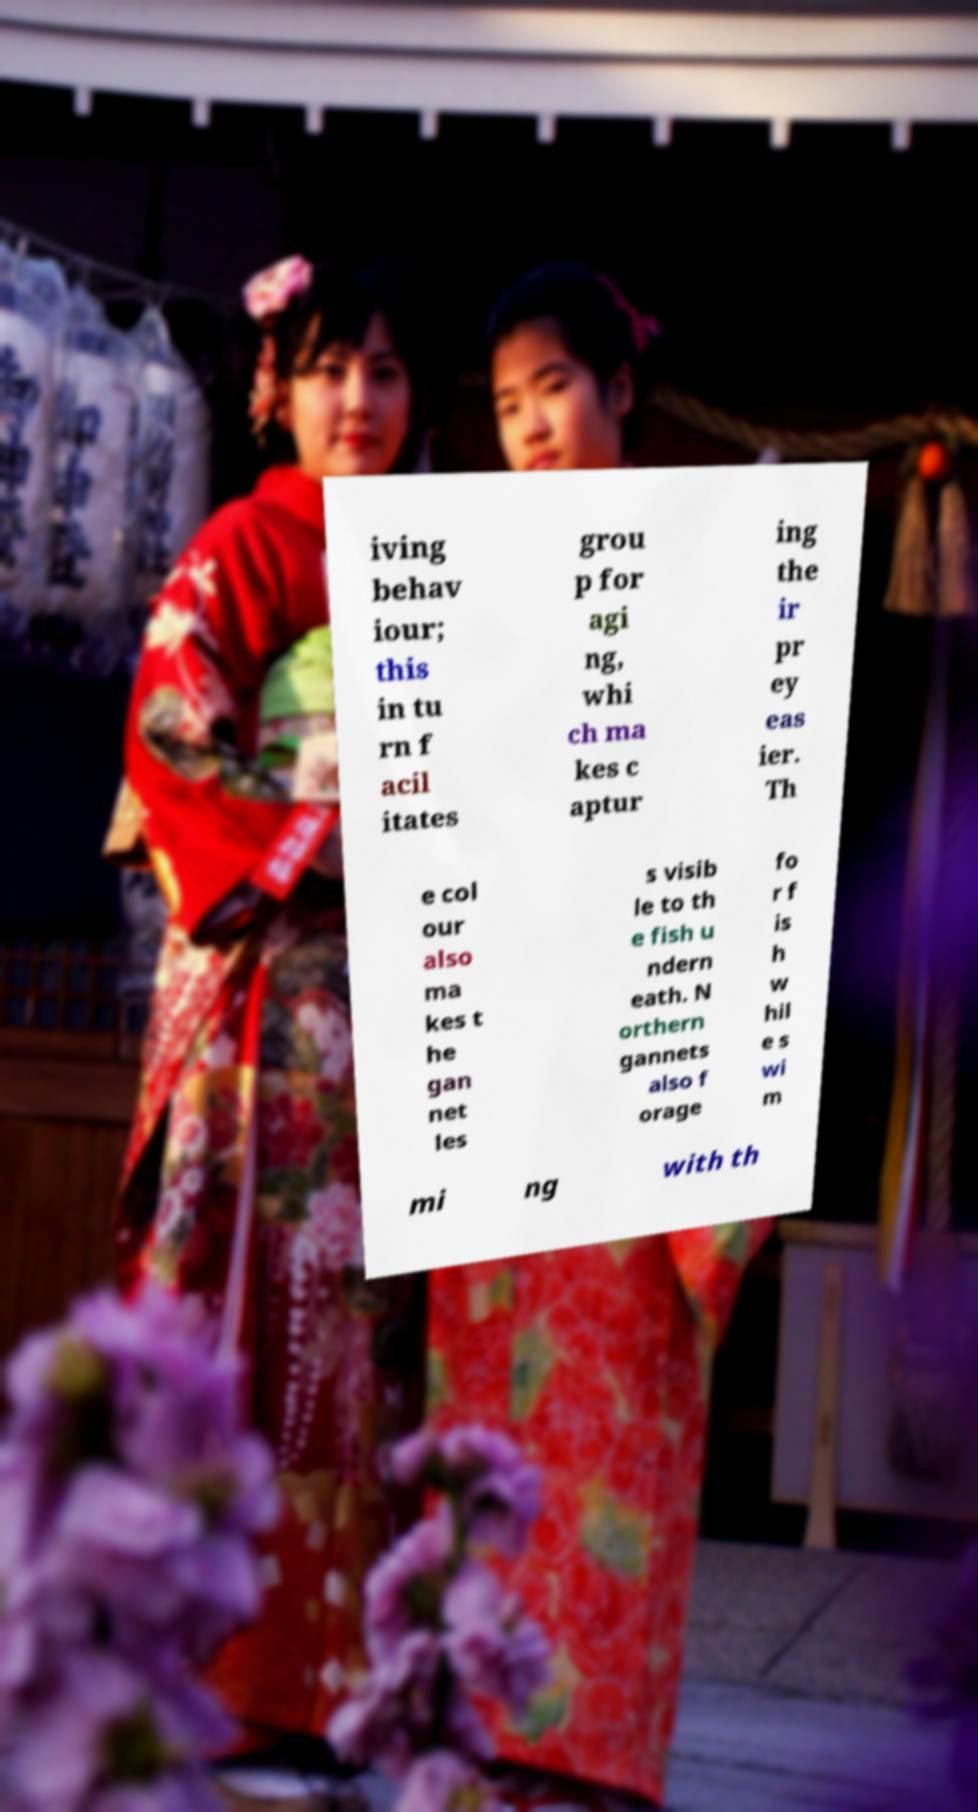Can you read and provide the text displayed in the image?This photo seems to have some interesting text. Can you extract and type it out for me? iving behav iour; this in tu rn f acil itates grou p for agi ng, whi ch ma kes c aptur ing the ir pr ey eas ier. Th e col our also ma kes t he gan net les s visib le to th e fish u ndern eath. N orthern gannets also f orage fo r f is h w hil e s wi m mi ng with th 